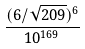<formula> <loc_0><loc_0><loc_500><loc_500>\frac { ( 6 / \sqrt { 2 0 9 } ) ^ { 6 } } { 1 0 ^ { 1 6 9 } }</formula> 